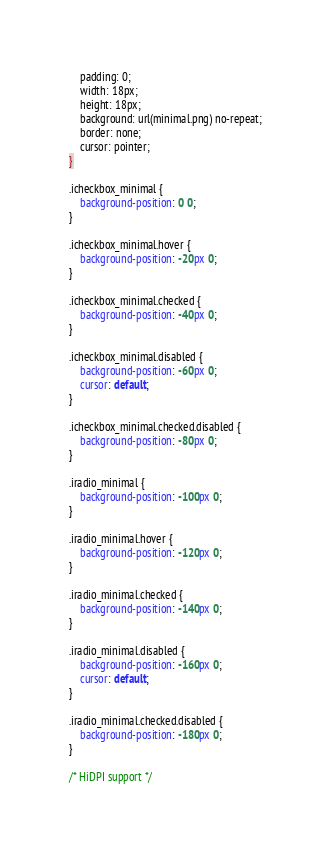Convert code to text. <code><loc_0><loc_0><loc_500><loc_500><_CSS_>    padding: 0;
    width: 18px;
    height: 18px;
    background: url(minimal.png) no-repeat;
    border: none;
    cursor: pointer;
}

.icheckbox_minimal {
    background-position: 0 0;
}

.icheckbox_minimal.hover {
    background-position: -20px 0;
}

.icheckbox_minimal.checked {
    background-position: -40px 0;
}

.icheckbox_minimal.disabled {
    background-position: -60px 0;
    cursor: default;
}

.icheckbox_minimal.checked.disabled {
    background-position: -80px 0;
}

.iradio_minimal {
    background-position: -100px 0;
}

.iradio_minimal.hover {
    background-position: -120px 0;
}

.iradio_minimal.checked {
    background-position: -140px 0;
}

.iradio_minimal.disabled {
    background-position: -160px 0;
    cursor: default;
}

.iradio_minimal.checked.disabled {
    background-position: -180px 0;
}

/* HiDPI support */</code> 